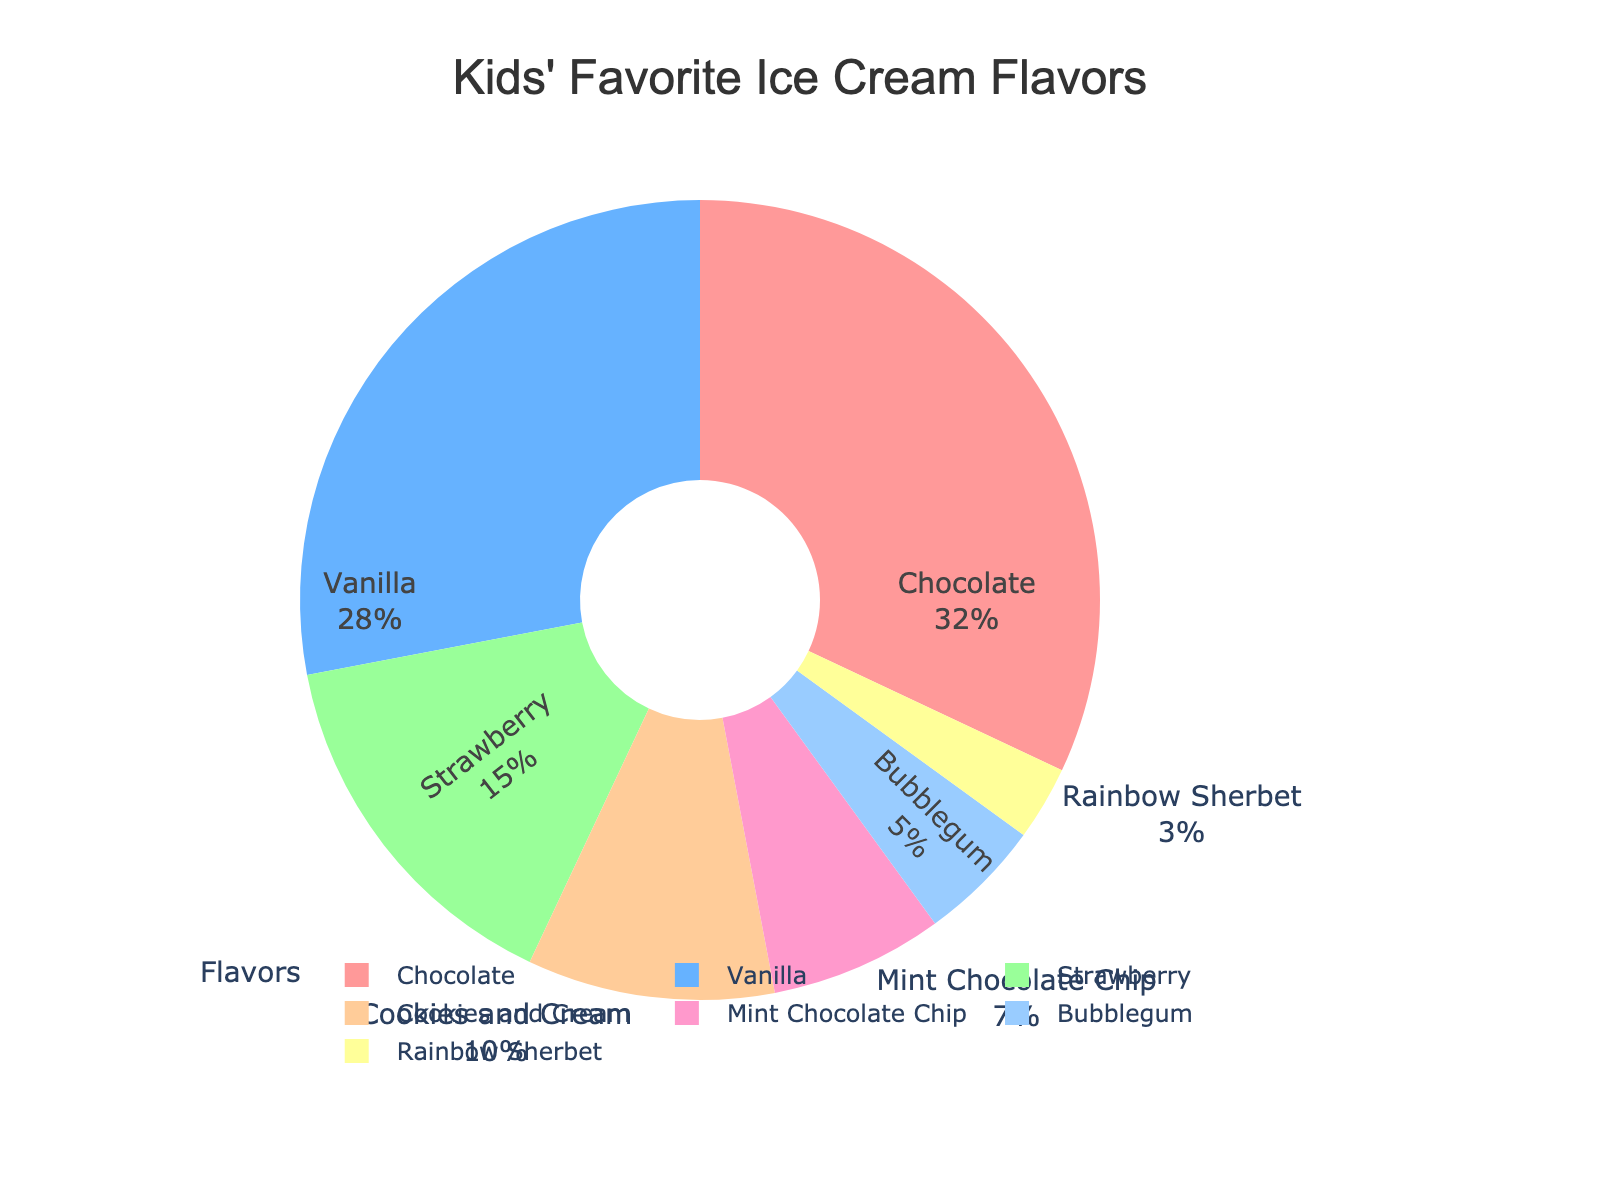What's the most popular ice cream flavor among the children? The most popular flavor is the one with the highest percentage. Looking at the figure, Chocolate has the largest portion of the pie chart.
Answer: Chocolate Which two flavors are the least popular? The least popular flavors will be the ones with the smallest percentages. From the figure, Bubblegum and Rainbow Sherbet have the smallest portions.
Answer: Bubblegum and Rainbow Sherbet What is the sum of the percentages for Vanilla and Strawberry? To find the sum, simply add the percentages for Vanilla and Strawberry. According to the figure, Vanilla is 28% and Strawberry is 15%. So, 28% + 15% = 43%.
Answer: 43% How much more popular is Chocolate than Mint Chocolate Chip? To determine how much more popular Chocolate is compared to Mint Chocolate Chip, subtract the percentage of Mint Chocolate Chip from Chocolate. Chocolate is 32% and Mint Chocolate Chip is 7%. So, 32% - 7% = 25%.
Answer: 25% Which flavors make up more than half of the preferences combined? To find this, sum the percentages of the top flavors until you reach more than 50%. Chocolate (32%) + Vanilla (28%) = 60%. Since 60% is more than half, Chocolate and Vanilla combined make up more than half.
Answer: Chocolate and Vanilla If Cookies and Cream and Bubblegum were combined into one category, would it be more popular than Vanilla? Combine the percentages of Cookies and Cream and Bubblegum: 10% + 5% = 15%. Compare this to Vanilla's 28%. Since 15% is less than 28%, it would not be more popular.
Answer: No What percentage of children prefer flavors other than Chocolate and Vanilla? Add Chocolate and Vanilla percentages first: 32% + 28% = 60%. Then subtract this from 100% to find the percentage for other flavors: 100% - 60% = 40%.
Answer: 40% Which flavor is closest in popularity to Cookies and Cream? Look for the flavor with a percentage close to Cookies and Cream's 10%. Mint Chocolate Chip at 7% is the closest in popularity.
Answer: Mint Chocolate Chip Are there any flavors with exactly the same popularity? Examine the percentages and see if any of them are identical. No two flavors share the same percentage.
Answer: No What is the average percentage preference for the top three flavors? First, find the top three flavors: Chocolate (32%), Vanilla (28%), and Strawberry (15%). Sum these percentages and divide by 3: (32% + 28% + 15%) / 3 = 75% / 3 = 25%.
Answer: 25% 